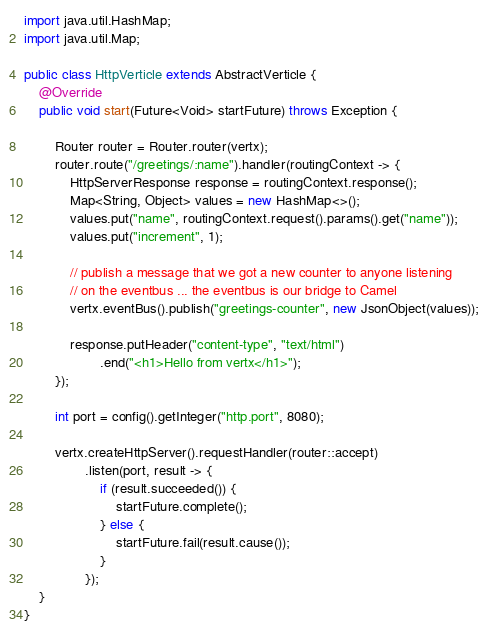Convert code to text. <code><loc_0><loc_0><loc_500><loc_500><_Java_>import java.util.HashMap;
import java.util.Map;

public class HttpVerticle extends AbstractVerticle {
    @Override
    public void start(Future<Void> startFuture) throws Exception {

        Router router = Router.router(vertx);
        router.route("/greetings/:name").handler(routingContext -> {
            HttpServerResponse response = routingContext.response();
            Map<String, Object> values = new HashMap<>();
            values.put("name", routingContext.request().params().get("name"));
            values.put("increment", 1);

            // publish a message that we got a new counter to anyone listening
            // on the eventbus ... the eventbus is our bridge to Camel
            vertx.eventBus().publish("greetings-counter", new JsonObject(values));

            response.putHeader("content-type", "text/html")
                    .end("<h1>Hello from vertx</h1>");
        });

        int port = config().getInteger("http.port", 8080);

        vertx.createHttpServer().requestHandler(router::accept)
                .listen(port, result -> {
                    if (result.succeeded()) {
                        startFuture.complete();
                    } else {
                        startFuture.fail(result.cause());
                    }
                });
    }
}
</code> 